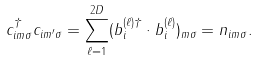<formula> <loc_0><loc_0><loc_500><loc_500>c ^ { \dagger } _ { i m \sigma } c _ { i m ^ { \prime } \sigma } = \sum ^ { 2 D } _ { \ell = 1 } ( { \sl b } _ { i } ^ { ( \ell ) \dagger } \cdot { \sl b } _ { i } ^ { ( \ell ) } ) _ { m \sigma } = n _ { i m \sigma } .</formula> 